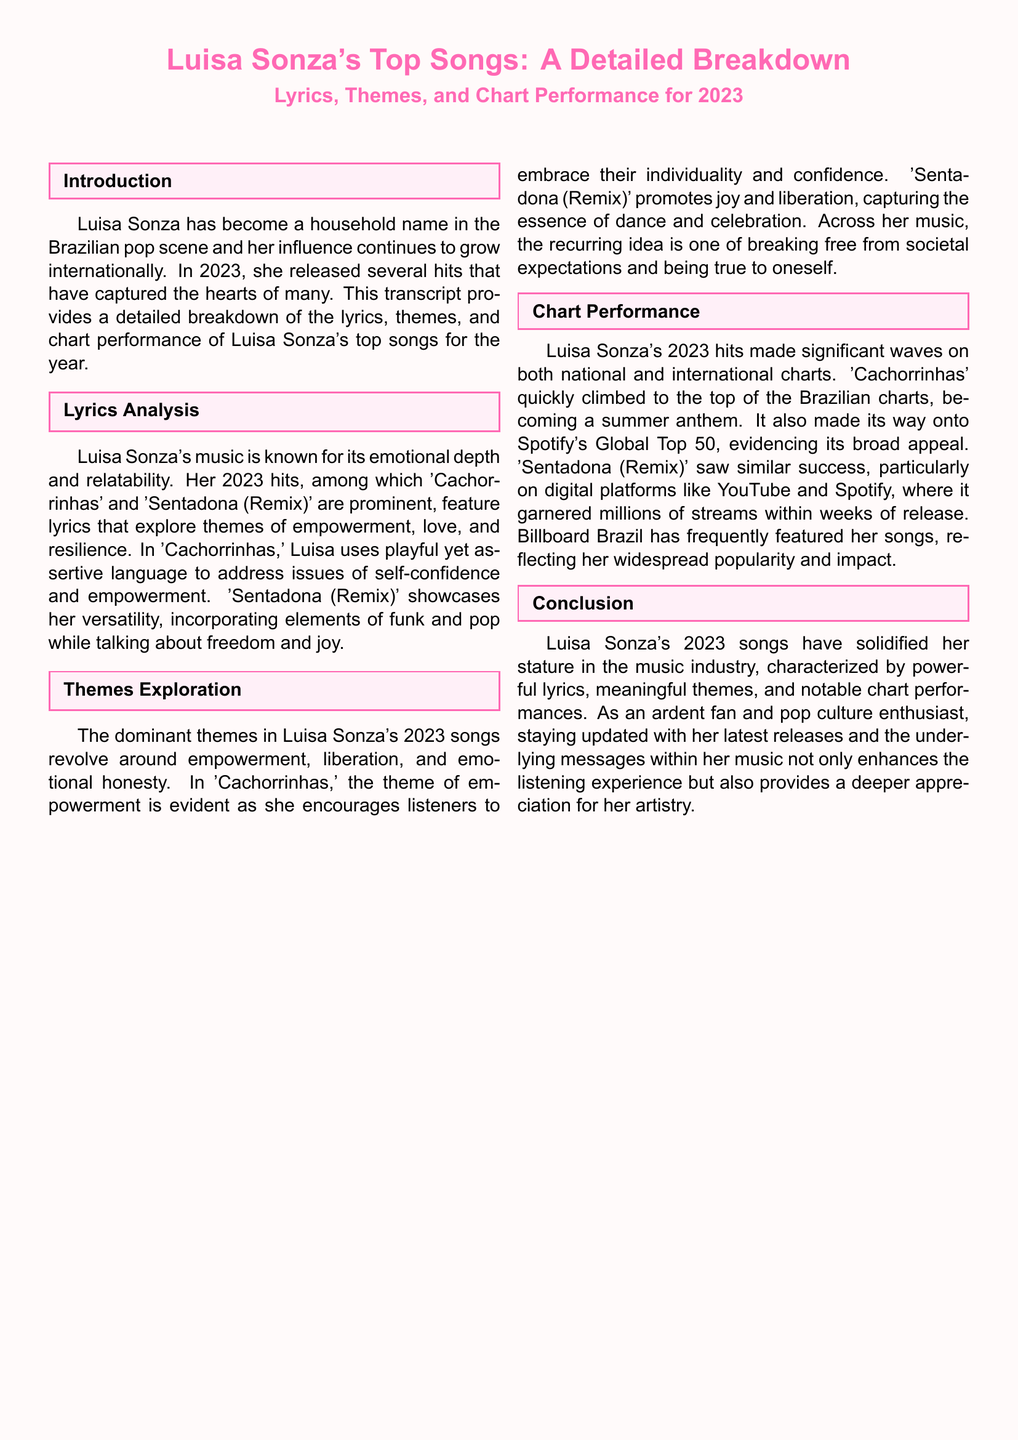What are Luisa Sonza's prominent songs in 2023? The prominent songs of Luisa Sonza in 2023 mentioned are 'Cachorrinhas' and 'Sentadona (Remix)'.
Answer: 'Cachorrinhas' and 'Sentadona (Remix)' What theme is prominent in 'Cachorrinhas'? The theme of empowerment is evident in 'Cachorrinhas' as she encourages individuality and confidence.
Answer: Empowerment How did 'Cachorrinhas' perform on the charts? 'Cachorrinhas' quickly climbed to the top of the Brazilian charts and made it onto Spotify's Global Top 50.
Answer: Top of Brazilian charts and Spotify's Global Top 50 What type of music does Luisa Sonza incorporate in 'Sentadona (Remix)'? 'Sentadona (Remix)' incorporates elements of funk and pop.
Answer: Funk and pop What is the underlying message of Luisa Sonza's music in 2023? The recurring idea is one of breaking free from societal expectations and being true to oneself.
Answer: Breaking free from societal expectations How many streams did 'Sentadona (Remix)' garner within weeks? 'Sentadona (Remix)' garnered millions of streams within weeks of release.
Answer: Millions What color represents the theme of the document? The pop color representing the theme is RGB 255,105,180.
Answer: RGB 255,105,180 What is the main focus area of the document? The main focus area of the document is a detailed breakdown of lyrics, themes, and chart performance of Luisa Sonza's top songs for 2023.
Answer: Detailed breakdown of lyrics, themes, and chart performance 